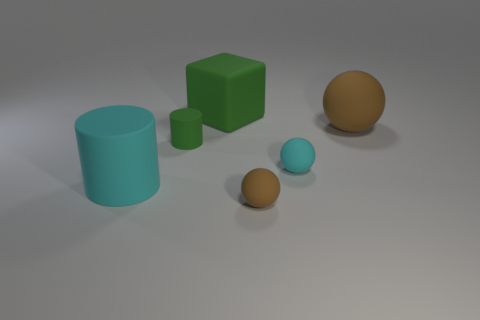The big rubber object that is both on the right side of the big cylinder and left of the tiny brown matte sphere has what shape?
Your response must be concise. Cube. There is a brown rubber object that is behind the cyan rubber object on the left side of the small brown matte thing; how big is it?
Make the answer very short. Large. What number of other rubber cylinders have the same color as the large rubber cylinder?
Provide a succinct answer. 0. There is a thing that is both behind the green matte cylinder and right of the cube; what is its size?
Offer a terse response. Large. How many brown things are the same shape as the tiny cyan rubber thing?
Offer a very short reply. 2. What is the material of the large cyan cylinder?
Offer a very short reply. Rubber. Is the shape of the big cyan thing the same as the big green matte thing?
Keep it short and to the point. No. Is there a tiny cyan thing that has the same material as the green cube?
Give a very brief answer. Yes. The big object that is behind the cyan matte sphere and on the left side of the small cyan rubber object is what color?
Make the answer very short. Green. What material is the cylinder that is to the left of the small matte cylinder?
Your response must be concise. Rubber. 